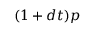<formula> <loc_0><loc_0><loc_500><loc_500>( 1 + d t ) p</formula> 